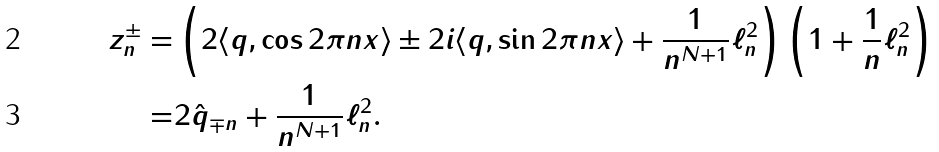<formula> <loc_0><loc_0><loc_500><loc_500>z _ { n } ^ { \pm } = & \left ( 2 \langle q , \cos 2 \pi n x \rangle \pm 2 i \langle q , \sin 2 \pi n x \rangle + \frac { 1 } { n ^ { N + 1 } } \ell ^ { 2 } _ { n } \right ) \left ( 1 + \frac { 1 } { n } \ell ^ { 2 } _ { n } \right ) \\ = & 2 \hat { q } _ { \mp n } + \frac { 1 } { n ^ { N + 1 } } \ell ^ { 2 } _ { n } .</formula> 